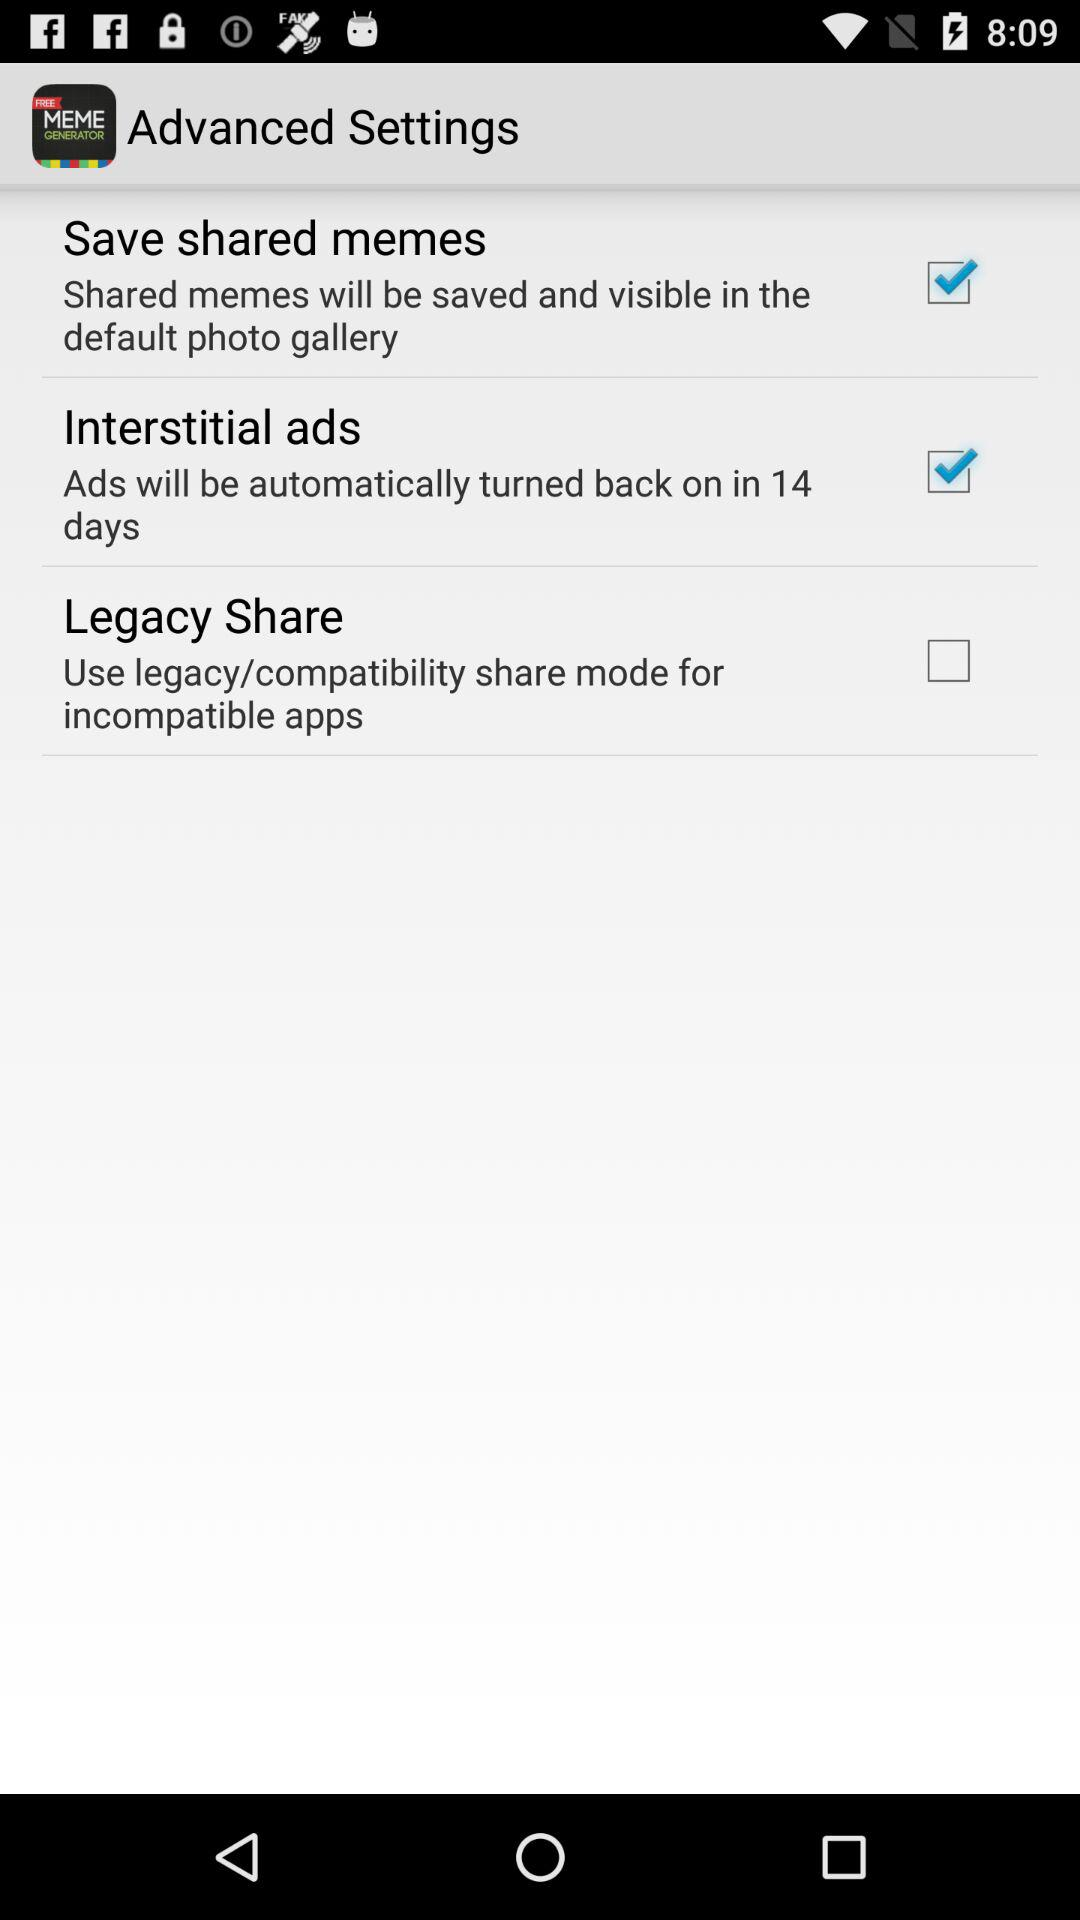How many items are in the Advanced Settings menu?
Answer the question using a single word or phrase. 3 